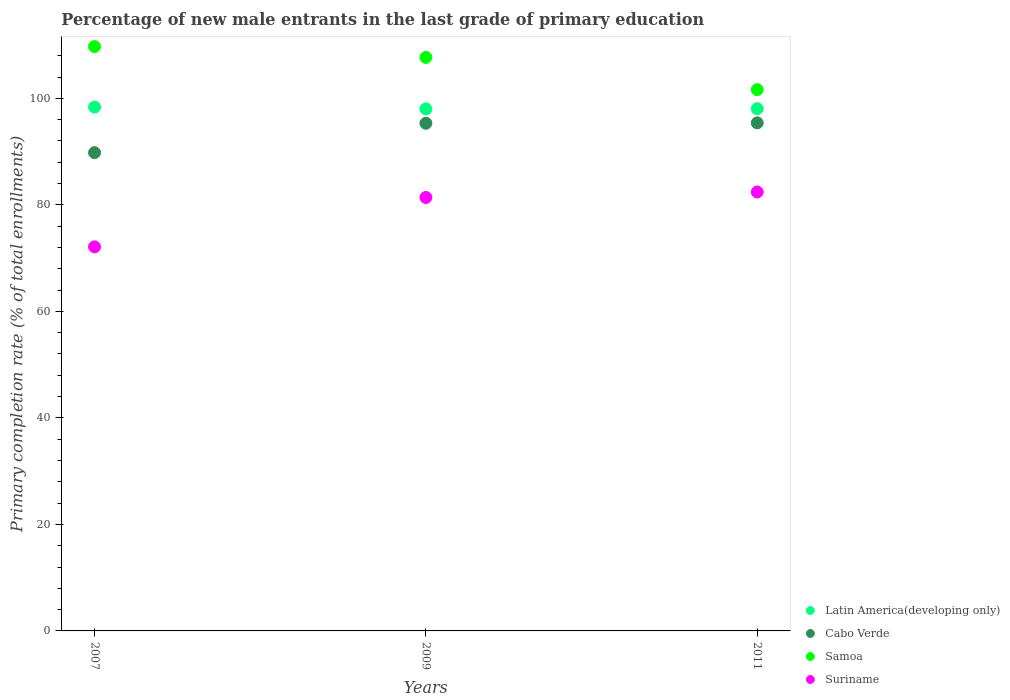What is the percentage of new male entrants in Latin America(developing only) in 2011?
Give a very brief answer. 98.06. Across all years, what is the maximum percentage of new male entrants in Samoa?
Keep it short and to the point. 109.71. Across all years, what is the minimum percentage of new male entrants in Samoa?
Your response must be concise. 101.63. In which year was the percentage of new male entrants in Suriname maximum?
Ensure brevity in your answer.  2011. In which year was the percentage of new male entrants in Latin America(developing only) minimum?
Ensure brevity in your answer.  2009. What is the total percentage of new male entrants in Suriname in the graph?
Your answer should be compact. 235.9. What is the difference between the percentage of new male entrants in Samoa in 2007 and that in 2009?
Your response must be concise. 2.03. What is the difference between the percentage of new male entrants in Samoa in 2007 and the percentage of new male entrants in Cabo Verde in 2009?
Your answer should be very brief. 14.4. What is the average percentage of new male entrants in Cabo Verde per year?
Keep it short and to the point. 93.5. In the year 2011, what is the difference between the percentage of new male entrants in Suriname and percentage of new male entrants in Latin America(developing only)?
Your answer should be compact. -15.65. What is the ratio of the percentage of new male entrants in Suriname in 2009 to that in 2011?
Ensure brevity in your answer.  0.99. Is the percentage of new male entrants in Suriname in 2007 less than that in 2009?
Keep it short and to the point. Yes. Is the difference between the percentage of new male entrants in Suriname in 2007 and 2011 greater than the difference between the percentage of new male entrants in Latin America(developing only) in 2007 and 2011?
Ensure brevity in your answer.  No. What is the difference between the highest and the second highest percentage of new male entrants in Latin America(developing only)?
Provide a short and direct response. 0.3. What is the difference between the highest and the lowest percentage of new male entrants in Cabo Verde?
Give a very brief answer. 5.59. In how many years, is the percentage of new male entrants in Cabo Verde greater than the average percentage of new male entrants in Cabo Verde taken over all years?
Offer a very short reply. 2. Is it the case that in every year, the sum of the percentage of new male entrants in Cabo Verde and percentage of new male entrants in Samoa  is greater than the sum of percentage of new male entrants in Latin America(developing only) and percentage of new male entrants in Suriname?
Offer a terse response. Yes. Is it the case that in every year, the sum of the percentage of new male entrants in Latin America(developing only) and percentage of new male entrants in Suriname  is greater than the percentage of new male entrants in Cabo Verde?
Your answer should be very brief. Yes. Does the percentage of new male entrants in Latin America(developing only) monotonically increase over the years?
Give a very brief answer. No. What is the difference between two consecutive major ticks on the Y-axis?
Your answer should be compact. 20. Are the values on the major ticks of Y-axis written in scientific E-notation?
Keep it short and to the point. No. Does the graph contain grids?
Ensure brevity in your answer.  No. How many legend labels are there?
Keep it short and to the point. 4. What is the title of the graph?
Provide a short and direct response. Percentage of new male entrants in the last grade of primary education. Does "Belize" appear as one of the legend labels in the graph?
Offer a terse response. No. What is the label or title of the Y-axis?
Offer a very short reply. Primary completion rate (% of total enrollments). What is the Primary completion rate (% of total enrollments) in Latin America(developing only) in 2007?
Keep it short and to the point. 98.35. What is the Primary completion rate (% of total enrollments) in Cabo Verde in 2007?
Your answer should be compact. 89.8. What is the Primary completion rate (% of total enrollments) in Samoa in 2007?
Your response must be concise. 109.71. What is the Primary completion rate (% of total enrollments) in Suriname in 2007?
Offer a very short reply. 72.11. What is the Primary completion rate (% of total enrollments) in Latin America(developing only) in 2009?
Your response must be concise. 98.02. What is the Primary completion rate (% of total enrollments) of Cabo Verde in 2009?
Provide a succinct answer. 95.31. What is the Primary completion rate (% of total enrollments) in Samoa in 2009?
Provide a succinct answer. 107.68. What is the Primary completion rate (% of total enrollments) in Suriname in 2009?
Your response must be concise. 81.38. What is the Primary completion rate (% of total enrollments) in Latin America(developing only) in 2011?
Your answer should be compact. 98.06. What is the Primary completion rate (% of total enrollments) in Cabo Verde in 2011?
Your response must be concise. 95.39. What is the Primary completion rate (% of total enrollments) in Samoa in 2011?
Your answer should be compact. 101.63. What is the Primary completion rate (% of total enrollments) of Suriname in 2011?
Your answer should be compact. 82.41. Across all years, what is the maximum Primary completion rate (% of total enrollments) of Latin America(developing only)?
Provide a short and direct response. 98.35. Across all years, what is the maximum Primary completion rate (% of total enrollments) of Cabo Verde?
Offer a very short reply. 95.39. Across all years, what is the maximum Primary completion rate (% of total enrollments) of Samoa?
Give a very brief answer. 109.71. Across all years, what is the maximum Primary completion rate (% of total enrollments) of Suriname?
Provide a succinct answer. 82.41. Across all years, what is the minimum Primary completion rate (% of total enrollments) of Latin America(developing only)?
Give a very brief answer. 98.02. Across all years, what is the minimum Primary completion rate (% of total enrollments) in Cabo Verde?
Keep it short and to the point. 89.8. Across all years, what is the minimum Primary completion rate (% of total enrollments) in Samoa?
Give a very brief answer. 101.63. Across all years, what is the minimum Primary completion rate (% of total enrollments) of Suriname?
Your answer should be compact. 72.11. What is the total Primary completion rate (% of total enrollments) in Latin America(developing only) in the graph?
Provide a succinct answer. 294.43. What is the total Primary completion rate (% of total enrollments) in Cabo Verde in the graph?
Your answer should be very brief. 280.49. What is the total Primary completion rate (% of total enrollments) of Samoa in the graph?
Provide a short and direct response. 319.02. What is the total Primary completion rate (% of total enrollments) in Suriname in the graph?
Offer a terse response. 235.9. What is the difference between the Primary completion rate (% of total enrollments) of Latin America(developing only) in 2007 and that in 2009?
Your answer should be very brief. 0.34. What is the difference between the Primary completion rate (% of total enrollments) in Cabo Verde in 2007 and that in 2009?
Provide a succinct answer. -5.51. What is the difference between the Primary completion rate (% of total enrollments) of Samoa in 2007 and that in 2009?
Offer a very short reply. 2.03. What is the difference between the Primary completion rate (% of total enrollments) in Suriname in 2007 and that in 2009?
Give a very brief answer. -9.27. What is the difference between the Primary completion rate (% of total enrollments) in Latin America(developing only) in 2007 and that in 2011?
Ensure brevity in your answer.  0.3. What is the difference between the Primary completion rate (% of total enrollments) of Cabo Verde in 2007 and that in 2011?
Provide a succinct answer. -5.59. What is the difference between the Primary completion rate (% of total enrollments) in Samoa in 2007 and that in 2011?
Offer a terse response. 8.08. What is the difference between the Primary completion rate (% of total enrollments) of Suriname in 2007 and that in 2011?
Make the answer very short. -10.3. What is the difference between the Primary completion rate (% of total enrollments) in Latin America(developing only) in 2009 and that in 2011?
Your answer should be very brief. -0.04. What is the difference between the Primary completion rate (% of total enrollments) in Cabo Verde in 2009 and that in 2011?
Offer a terse response. -0.08. What is the difference between the Primary completion rate (% of total enrollments) in Samoa in 2009 and that in 2011?
Your answer should be very brief. 6.05. What is the difference between the Primary completion rate (% of total enrollments) of Suriname in 2009 and that in 2011?
Provide a short and direct response. -1.03. What is the difference between the Primary completion rate (% of total enrollments) of Latin America(developing only) in 2007 and the Primary completion rate (% of total enrollments) of Cabo Verde in 2009?
Your response must be concise. 3.04. What is the difference between the Primary completion rate (% of total enrollments) of Latin America(developing only) in 2007 and the Primary completion rate (% of total enrollments) of Samoa in 2009?
Provide a succinct answer. -9.32. What is the difference between the Primary completion rate (% of total enrollments) of Latin America(developing only) in 2007 and the Primary completion rate (% of total enrollments) of Suriname in 2009?
Give a very brief answer. 16.97. What is the difference between the Primary completion rate (% of total enrollments) of Cabo Verde in 2007 and the Primary completion rate (% of total enrollments) of Samoa in 2009?
Offer a terse response. -17.88. What is the difference between the Primary completion rate (% of total enrollments) in Cabo Verde in 2007 and the Primary completion rate (% of total enrollments) in Suriname in 2009?
Offer a very short reply. 8.42. What is the difference between the Primary completion rate (% of total enrollments) in Samoa in 2007 and the Primary completion rate (% of total enrollments) in Suriname in 2009?
Offer a terse response. 28.33. What is the difference between the Primary completion rate (% of total enrollments) in Latin America(developing only) in 2007 and the Primary completion rate (% of total enrollments) in Cabo Verde in 2011?
Ensure brevity in your answer.  2.96. What is the difference between the Primary completion rate (% of total enrollments) in Latin America(developing only) in 2007 and the Primary completion rate (% of total enrollments) in Samoa in 2011?
Provide a short and direct response. -3.28. What is the difference between the Primary completion rate (% of total enrollments) in Latin America(developing only) in 2007 and the Primary completion rate (% of total enrollments) in Suriname in 2011?
Offer a terse response. 15.94. What is the difference between the Primary completion rate (% of total enrollments) in Cabo Verde in 2007 and the Primary completion rate (% of total enrollments) in Samoa in 2011?
Give a very brief answer. -11.84. What is the difference between the Primary completion rate (% of total enrollments) of Cabo Verde in 2007 and the Primary completion rate (% of total enrollments) of Suriname in 2011?
Your response must be concise. 7.39. What is the difference between the Primary completion rate (% of total enrollments) of Samoa in 2007 and the Primary completion rate (% of total enrollments) of Suriname in 2011?
Make the answer very short. 27.3. What is the difference between the Primary completion rate (% of total enrollments) of Latin America(developing only) in 2009 and the Primary completion rate (% of total enrollments) of Cabo Verde in 2011?
Offer a very short reply. 2.63. What is the difference between the Primary completion rate (% of total enrollments) in Latin America(developing only) in 2009 and the Primary completion rate (% of total enrollments) in Samoa in 2011?
Offer a very short reply. -3.62. What is the difference between the Primary completion rate (% of total enrollments) in Latin America(developing only) in 2009 and the Primary completion rate (% of total enrollments) in Suriname in 2011?
Your answer should be very brief. 15.61. What is the difference between the Primary completion rate (% of total enrollments) in Cabo Verde in 2009 and the Primary completion rate (% of total enrollments) in Samoa in 2011?
Keep it short and to the point. -6.32. What is the difference between the Primary completion rate (% of total enrollments) in Cabo Verde in 2009 and the Primary completion rate (% of total enrollments) in Suriname in 2011?
Ensure brevity in your answer.  12.9. What is the difference between the Primary completion rate (% of total enrollments) of Samoa in 2009 and the Primary completion rate (% of total enrollments) of Suriname in 2011?
Provide a succinct answer. 25.27. What is the average Primary completion rate (% of total enrollments) in Latin America(developing only) per year?
Your answer should be compact. 98.14. What is the average Primary completion rate (% of total enrollments) in Cabo Verde per year?
Make the answer very short. 93.5. What is the average Primary completion rate (% of total enrollments) of Samoa per year?
Your response must be concise. 106.34. What is the average Primary completion rate (% of total enrollments) of Suriname per year?
Make the answer very short. 78.63. In the year 2007, what is the difference between the Primary completion rate (% of total enrollments) in Latin America(developing only) and Primary completion rate (% of total enrollments) in Cabo Verde?
Keep it short and to the point. 8.56. In the year 2007, what is the difference between the Primary completion rate (% of total enrollments) of Latin America(developing only) and Primary completion rate (% of total enrollments) of Samoa?
Provide a short and direct response. -11.36. In the year 2007, what is the difference between the Primary completion rate (% of total enrollments) of Latin America(developing only) and Primary completion rate (% of total enrollments) of Suriname?
Keep it short and to the point. 26.24. In the year 2007, what is the difference between the Primary completion rate (% of total enrollments) of Cabo Verde and Primary completion rate (% of total enrollments) of Samoa?
Offer a terse response. -19.91. In the year 2007, what is the difference between the Primary completion rate (% of total enrollments) of Cabo Verde and Primary completion rate (% of total enrollments) of Suriname?
Provide a short and direct response. 17.69. In the year 2007, what is the difference between the Primary completion rate (% of total enrollments) in Samoa and Primary completion rate (% of total enrollments) in Suriname?
Give a very brief answer. 37.6. In the year 2009, what is the difference between the Primary completion rate (% of total enrollments) in Latin America(developing only) and Primary completion rate (% of total enrollments) in Cabo Verde?
Offer a very short reply. 2.71. In the year 2009, what is the difference between the Primary completion rate (% of total enrollments) of Latin America(developing only) and Primary completion rate (% of total enrollments) of Samoa?
Make the answer very short. -9.66. In the year 2009, what is the difference between the Primary completion rate (% of total enrollments) of Latin America(developing only) and Primary completion rate (% of total enrollments) of Suriname?
Provide a succinct answer. 16.64. In the year 2009, what is the difference between the Primary completion rate (% of total enrollments) of Cabo Verde and Primary completion rate (% of total enrollments) of Samoa?
Your answer should be very brief. -12.37. In the year 2009, what is the difference between the Primary completion rate (% of total enrollments) of Cabo Verde and Primary completion rate (% of total enrollments) of Suriname?
Keep it short and to the point. 13.93. In the year 2009, what is the difference between the Primary completion rate (% of total enrollments) in Samoa and Primary completion rate (% of total enrollments) in Suriname?
Provide a short and direct response. 26.3. In the year 2011, what is the difference between the Primary completion rate (% of total enrollments) of Latin America(developing only) and Primary completion rate (% of total enrollments) of Cabo Verde?
Offer a very short reply. 2.67. In the year 2011, what is the difference between the Primary completion rate (% of total enrollments) of Latin America(developing only) and Primary completion rate (% of total enrollments) of Samoa?
Your response must be concise. -3.57. In the year 2011, what is the difference between the Primary completion rate (% of total enrollments) of Latin America(developing only) and Primary completion rate (% of total enrollments) of Suriname?
Provide a succinct answer. 15.65. In the year 2011, what is the difference between the Primary completion rate (% of total enrollments) in Cabo Verde and Primary completion rate (% of total enrollments) in Samoa?
Offer a terse response. -6.24. In the year 2011, what is the difference between the Primary completion rate (% of total enrollments) of Cabo Verde and Primary completion rate (% of total enrollments) of Suriname?
Your response must be concise. 12.98. In the year 2011, what is the difference between the Primary completion rate (% of total enrollments) of Samoa and Primary completion rate (% of total enrollments) of Suriname?
Provide a succinct answer. 19.22. What is the ratio of the Primary completion rate (% of total enrollments) in Cabo Verde in 2007 to that in 2009?
Your answer should be compact. 0.94. What is the ratio of the Primary completion rate (% of total enrollments) in Samoa in 2007 to that in 2009?
Your answer should be compact. 1.02. What is the ratio of the Primary completion rate (% of total enrollments) of Suriname in 2007 to that in 2009?
Provide a short and direct response. 0.89. What is the ratio of the Primary completion rate (% of total enrollments) in Latin America(developing only) in 2007 to that in 2011?
Provide a succinct answer. 1. What is the ratio of the Primary completion rate (% of total enrollments) in Cabo Verde in 2007 to that in 2011?
Give a very brief answer. 0.94. What is the ratio of the Primary completion rate (% of total enrollments) in Samoa in 2007 to that in 2011?
Offer a very short reply. 1.08. What is the ratio of the Primary completion rate (% of total enrollments) in Suriname in 2007 to that in 2011?
Offer a very short reply. 0.88. What is the ratio of the Primary completion rate (% of total enrollments) in Samoa in 2009 to that in 2011?
Offer a terse response. 1.06. What is the ratio of the Primary completion rate (% of total enrollments) of Suriname in 2009 to that in 2011?
Provide a short and direct response. 0.99. What is the difference between the highest and the second highest Primary completion rate (% of total enrollments) of Latin America(developing only)?
Your answer should be compact. 0.3. What is the difference between the highest and the second highest Primary completion rate (% of total enrollments) in Cabo Verde?
Your answer should be very brief. 0.08. What is the difference between the highest and the second highest Primary completion rate (% of total enrollments) in Samoa?
Your answer should be compact. 2.03. What is the difference between the highest and the second highest Primary completion rate (% of total enrollments) of Suriname?
Make the answer very short. 1.03. What is the difference between the highest and the lowest Primary completion rate (% of total enrollments) of Latin America(developing only)?
Ensure brevity in your answer.  0.34. What is the difference between the highest and the lowest Primary completion rate (% of total enrollments) in Cabo Verde?
Your answer should be very brief. 5.59. What is the difference between the highest and the lowest Primary completion rate (% of total enrollments) of Samoa?
Your answer should be compact. 8.08. What is the difference between the highest and the lowest Primary completion rate (% of total enrollments) in Suriname?
Keep it short and to the point. 10.3. 